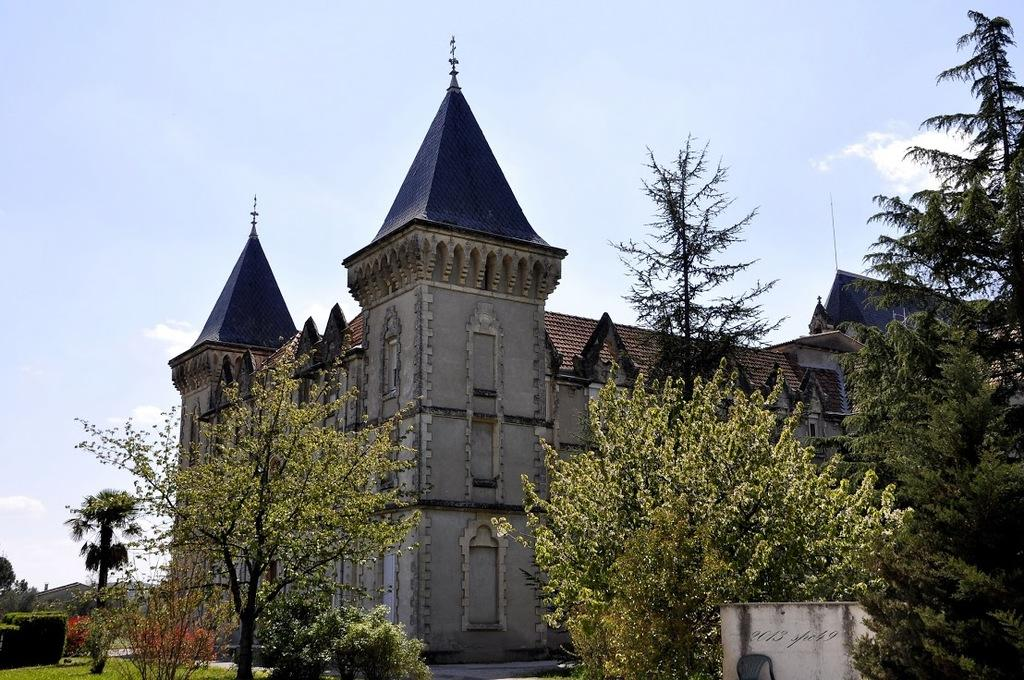What type of structure is present in the image? There is a building in the image. What natural elements can be seen in the image? There are trees, plants, and grass visible in the image. What is visible in the background of the image? The sky is visible in the image, and there are clouds present. What type of trousers are the clouds wearing in the image? The clouds are not wearing trousers, as they are a natural atmospheric phenomenon and not human-like entities. 